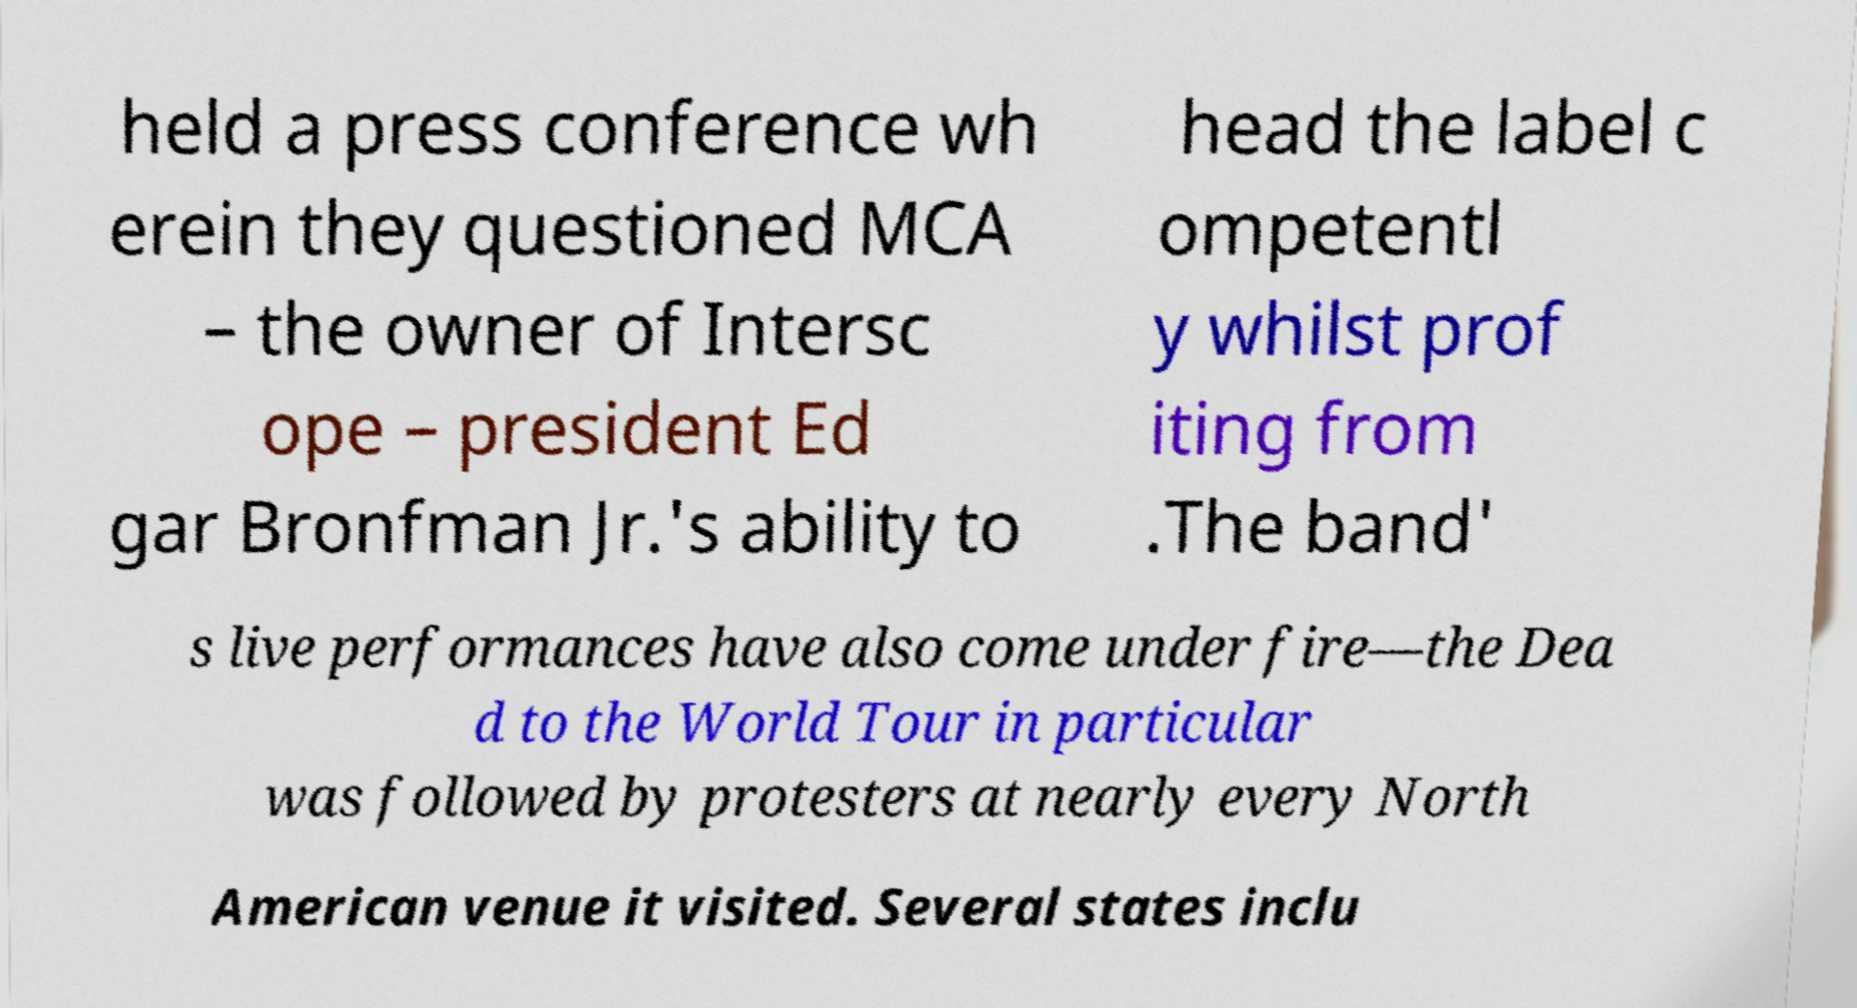Could you assist in decoding the text presented in this image and type it out clearly? held a press conference wh erein they questioned MCA – the owner of Intersc ope – president Ed gar Bronfman Jr.'s ability to head the label c ompetentl y whilst prof iting from .The band' s live performances have also come under fire—the Dea d to the World Tour in particular was followed by protesters at nearly every North American venue it visited. Several states inclu 